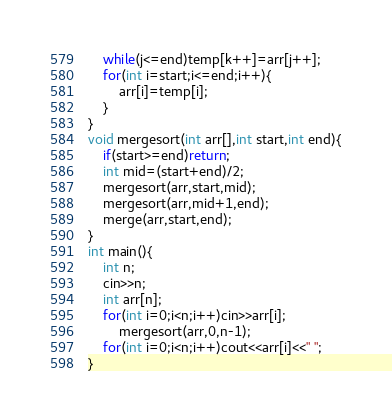Convert code to text. <code><loc_0><loc_0><loc_500><loc_500><_C++_>	while(j<=end)temp[k++]=arr[j++];
	for(int i=start;i<=end;i++){
		arr[i]=temp[i];
	}
}
void mergesort(int arr[],int start,int end){
	if(start>=end)return;
	int mid=(start+end)/2;
	mergesort(arr,start,mid);
	mergesort(arr,mid+1,end);
	merge(arr,start,end);
}
int main(){
	int n;
	cin>>n;
	int arr[n];
	for(int i=0;i<n;i++)cin>>arr[i];
		mergesort(arr,0,n-1);
	for(int i=0;i<n;i++)cout<<arr[i]<<" ";
}</code> 